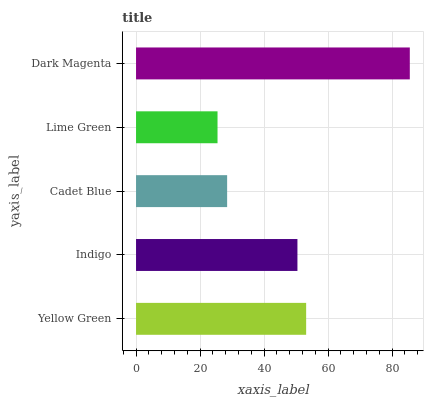Is Lime Green the minimum?
Answer yes or no. Yes. Is Dark Magenta the maximum?
Answer yes or no. Yes. Is Indigo the minimum?
Answer yes or no. No. Is Indigo the maximum?
Answer yes or no. No. Is Yellow Green greater than Indigo?
Answer yes or no. Yes. Is Indigo less than Yellow Green?
Answer yes or no. Yes. Is Indigo greater than Yellow Green?
Answer yes or no. No. Is Yellow Green less than Indigo?
Answer yes or no. No. Is Indigo the high median?
Answer yes or no. Yes. Is Indigo the low median?
Answer yes or no. Yes. Is Yellow Green the high median?
Answer yes or no. No. Is Cadet Blue the low median?
Answer yes or no. No. 